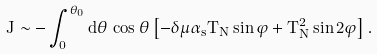Convert formula to latex. <formula><loc_0><loc_0><loc_500><loc_500>J \sim - \int _ { 0 } ^ { \theta _ { 0 } } d \theta \, \cos \theta \left [ - \delta \mu \alpha _ { s } T _ { N } \sin \varphi + T _ { N } ^ { 2 } \sin 2 \varphi \right ] .</formula> 